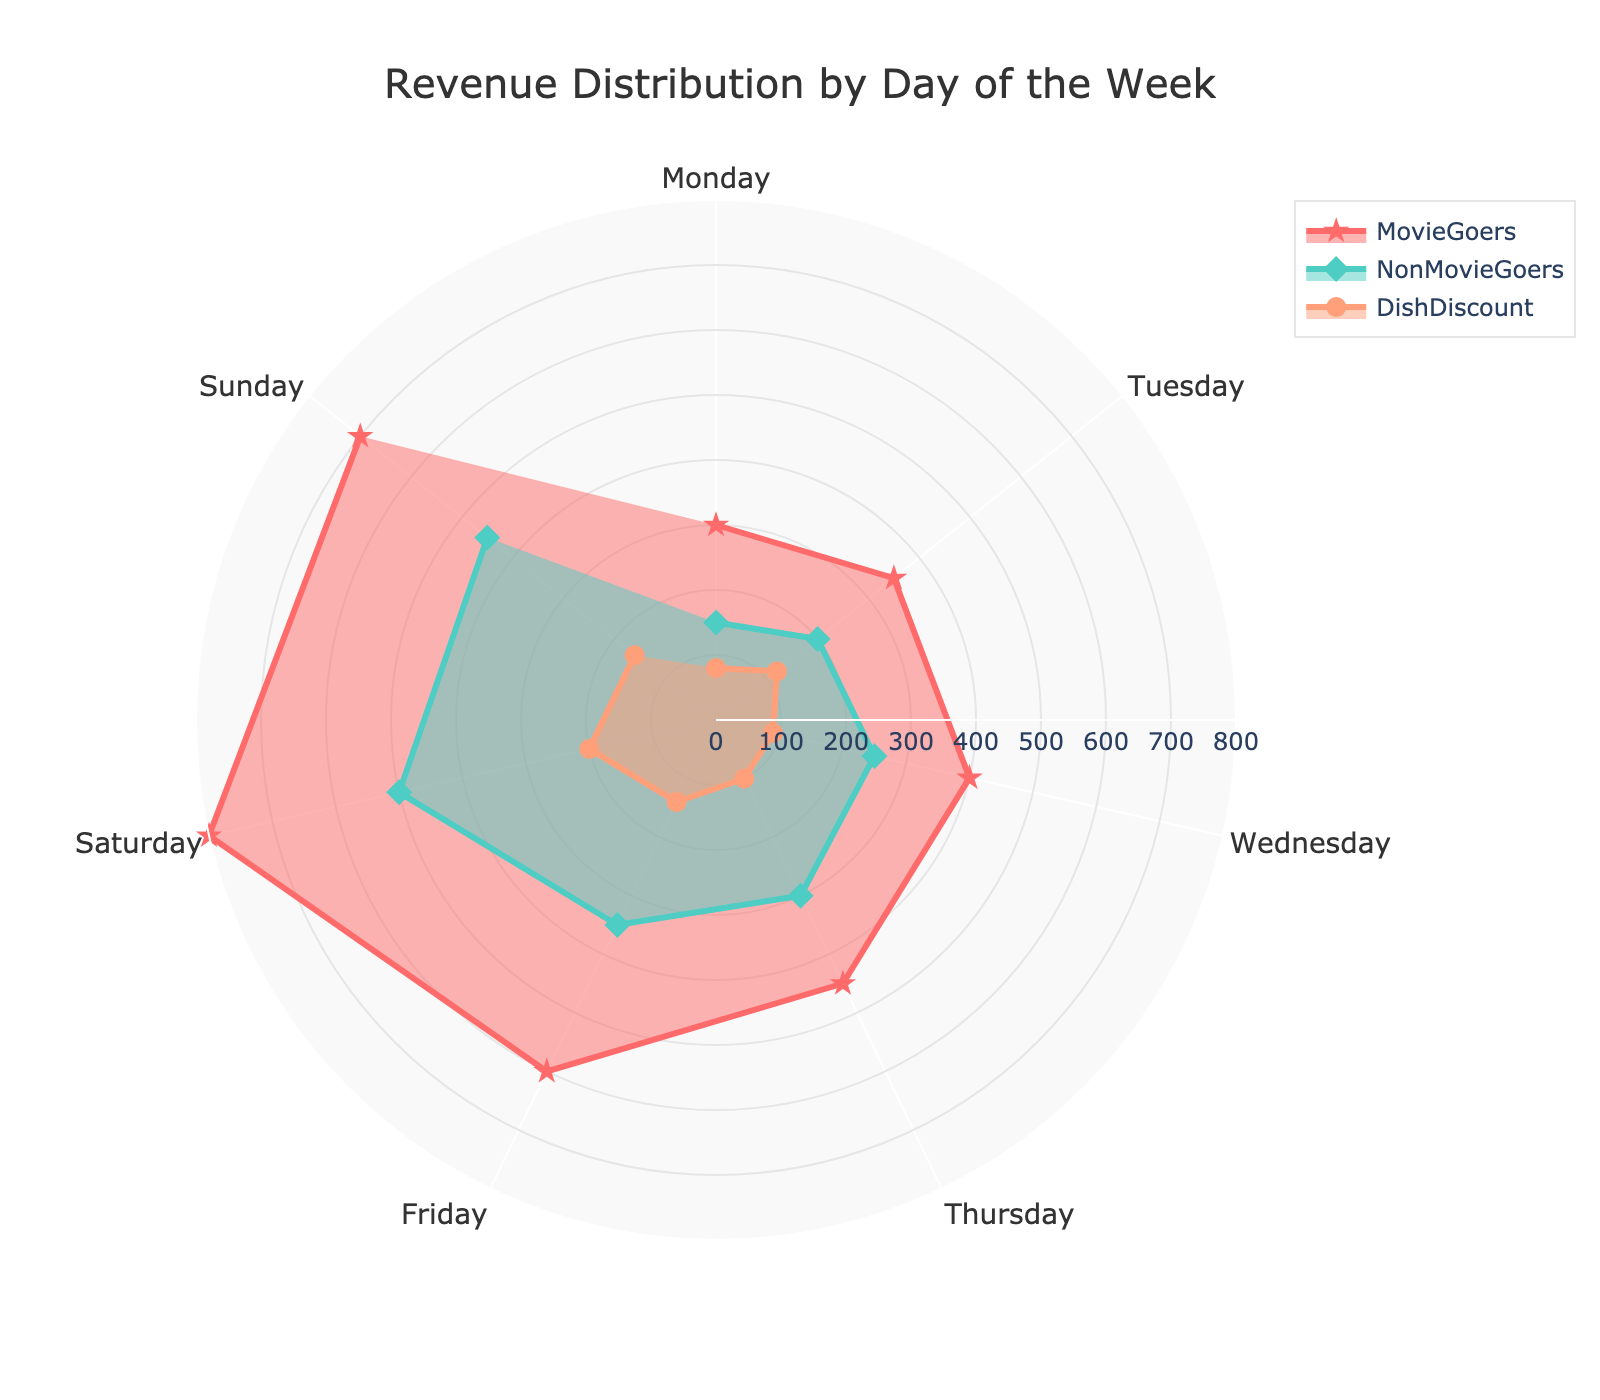What is the title of the radar chart? The title of the radar chart is usually displayed at the top center of the figure. In this case, the title reads "Revenue Distribution by Day of the Week".
Answer: Revenue Distribution by Day of the Week Which group has the highest value on Saturday? By looking at the radar chart, you can compare the values of MovieGoers, NonMovieGoers, and DishDiscount for Saturday. The MovieGoers group has the highest value on Saturday.
Answer: MovieGoers What is the average revenue distribution for MovieGoers over the week? To find the average revenue for MovieGoers, sum the values for each day and divide by the number of days: (300 + 350 + 400 + 450 + 600 + 800 + 700)/7 = 3600/7 ≈ 514.3.
Answer: 514.3 On which day does the DishDiscount group have its peak value? By looking at the radar chart, you can identify that the DishDiscount group peaks on Saturday with a value of 200.
Answer: Saturday Compare the revenue of NonMovieGoers and MovieGoers on Wednesday. Which one is higher and by how much? By referencing the radar chart, the revenue for NonMovieGoers on Wednesday is 250 and for MovieGoers it is 400. The difference is 400 - 250 = 150, with MovieGoers having the higher revenue.
Answer: MovieGoers by 150 What is the trend of the MovieGoers values from Monday to Sunday? Observing the radar chart, the values for MovieGoers increase consistently from Monday (300) to Saturday (800) and slightly decrease on Sunday (700).
Answer: Increasing till Saturday and then decreasing Which day has the lowest revenue for NonMovieGoers and what is the value? By examining the radar chart, you can see that the lowest revenue for NonMovieGoers is on Monday, with a value of 150.
Answer: Monday, 150 What’s the total revenue for DishDiscount over the weekend (Saturday and Sunday)? Summing the values for Saturday (200) and Sunday (160) for DishDiscount gives 200 + 160 = 360.
Answer: 360 How does the revenue for DishDiscount on Thursday compare to that on Monday? Looking at the radar chart, the revenue for DishDiscount on Thursday is 100 and on Monday it is 80. The difference is 100 - 80 = 20, with Thursday having the higher revenue.
Answer: Thursday by 20 